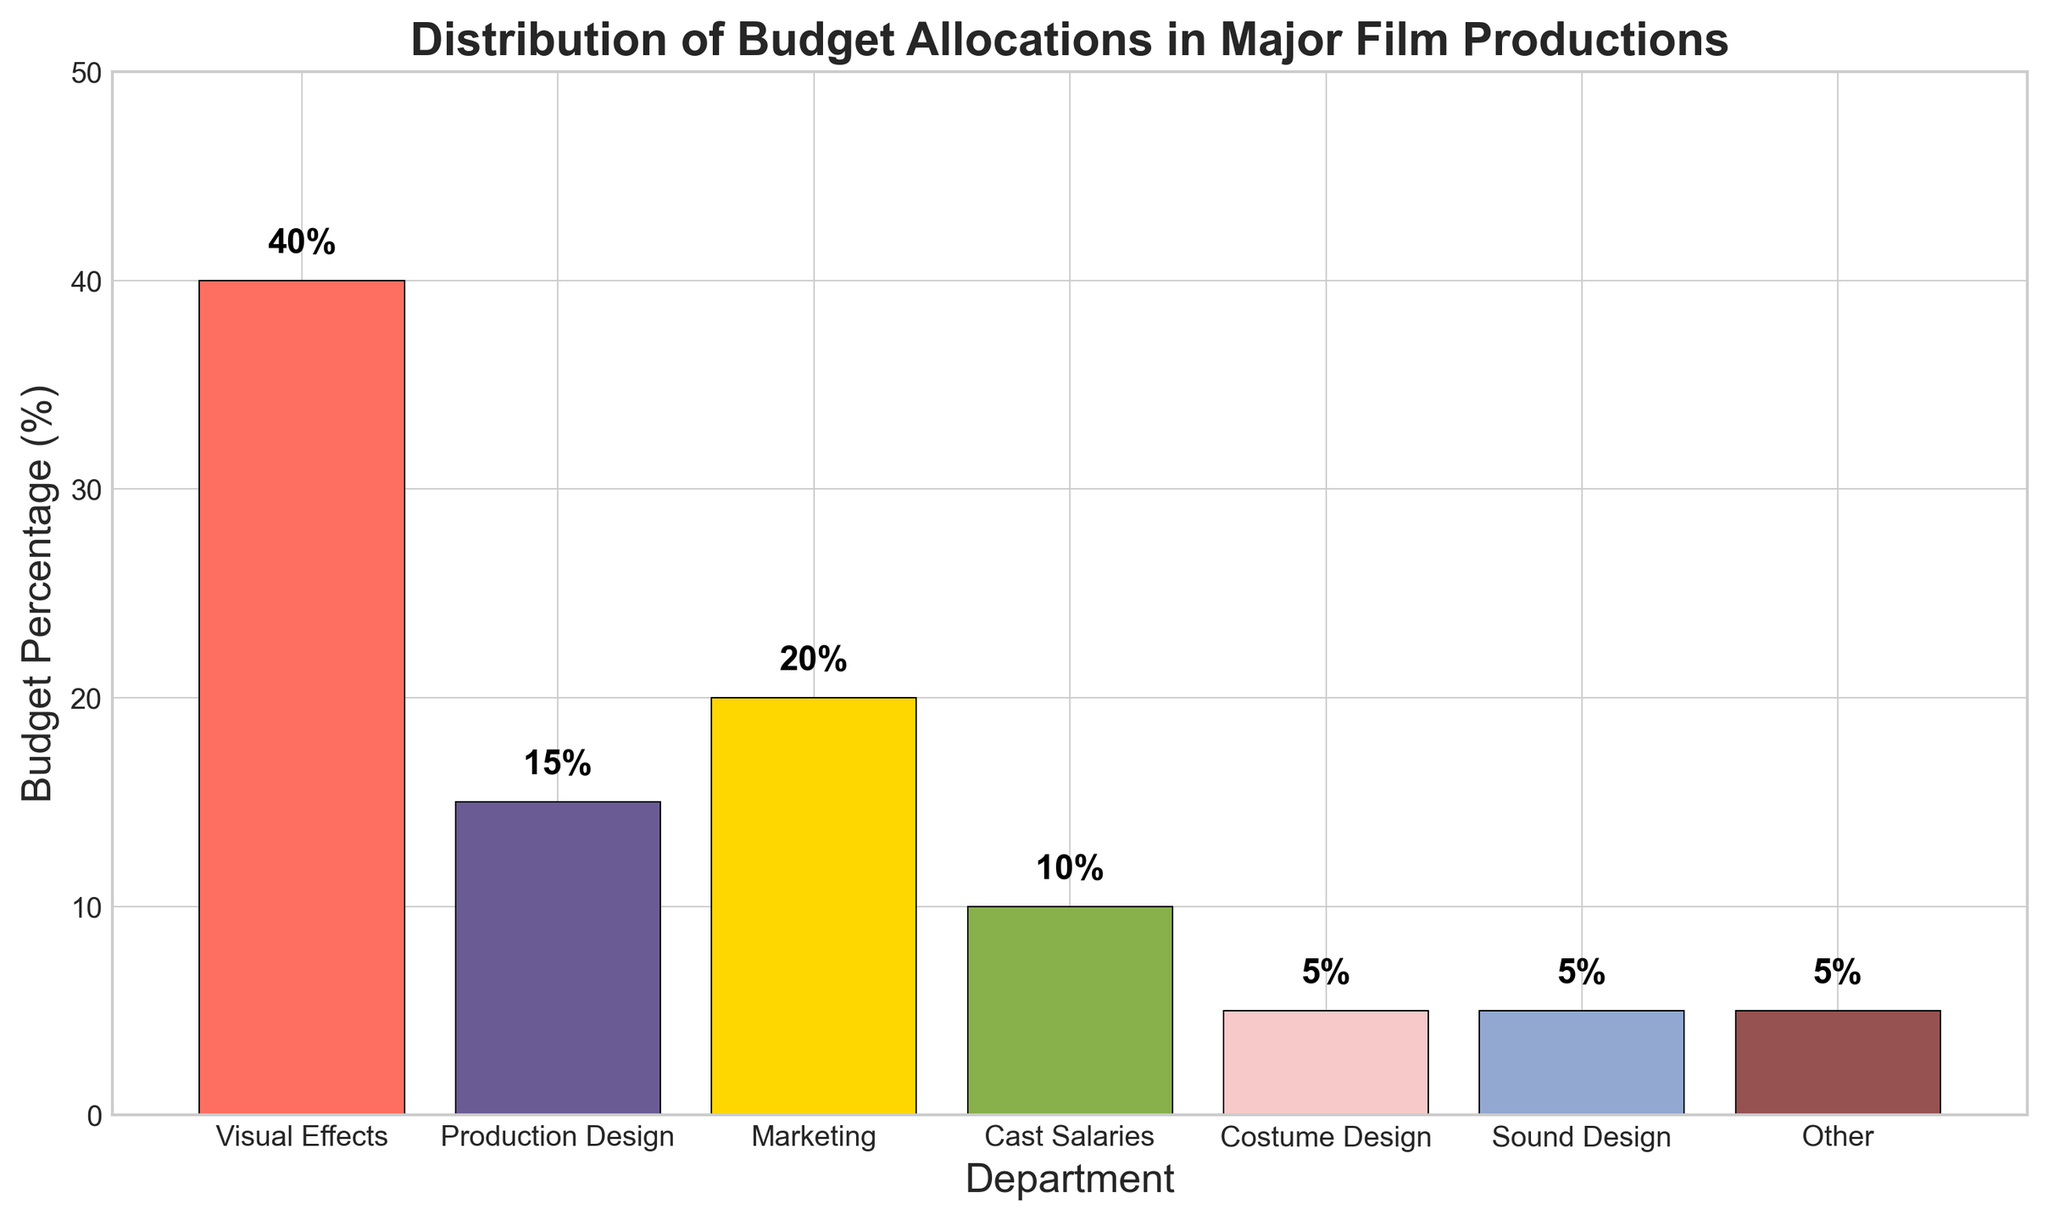What is the percentage of the budget allocated to Visual Effects? Visual Effects has one of the bars in the chart, and the percentage value is labeled directly on it. The label reads 40%.
Answer: 40% Which department has the smallest budget allocation, and what is it? By looking at the height of the bars and their labels, the smallest values are for Costume Design, Sound Design, and Other, each with a budget percentage of 5%.
Answer: Costume Design, Sound Design, and Other; 5% How do the budget percentages for Production Design and Marketing compare? The bar for Production Design is labeled with 15%, and the bar for Marketing is labeled with 20%. Therefore, Marketing has a higher budget allocation than Production Design.
Answer: Marketing has a higher budget allocation than Production Design What is the total budget percentage allocated to Costume Design, Sound Design, and Other combined? Add the budget percentages of Costume Design (5%), Sound Design (5%), and Other (5%). This makes 5% + 5% + 5% = 15%.
Answer: 15% Which department has the highest budget allocation, and how much more is it compared to the department with the second-highest allocation? The highest budget allocation is for Visual Effects at 40%, and the second-highest is Marketing at 20%. The difference is 40% - 20% = 20%.
Answer: Visual Effects; 20% What is the average budget percentage of Cast Salaries, Production Design, and Costume Design? To find the average, first sum the percentages: Cast Salaries (10%) + Production Design (15%) + Costume Design (5%) = 30%. Then divide by the number of departments: 30% / 3 = 10%.
Answer: 10% Are there any departments with equal budget allocations? If so, which ones? By looking at the labeled percentages on the bars, Costume Design, Sound Design, and Other all have the same allocation of 5%.
Answer: Costume Design, Sound Design, and Other What is the collective percentage of the budget allocated to Production Design and Sound Design? Add the budget percentages for Production Design (15%) and Sound Design (5%). This makes 15% + 5% = 20%.
Answer: 20% If the percentage allocated to Visual Effects were reduced by 10%, what would the new allocation be and how would it compare to the Marketing allocation? Reducing the Visual Effects budget by 10% from 40% results in 40% - 10% = 30%. The Marketing allocation is 20%, so the new Visual Effects allocation would still be higher by 10%.
Answer: 30%; it would still be 10% more than Marketing What is the difference between the collective budget percentages of Visual Effects and Cast Salaries versus that of Production Design and Marketing? Sum the percentages for Visual Effects (40%) and Cast Salaries (10%) to get 50%. Sum Production Design (15%) and Marketing (20%) to get 35%. The difference is 50% - 35% = 15%.
Answer: 15% 